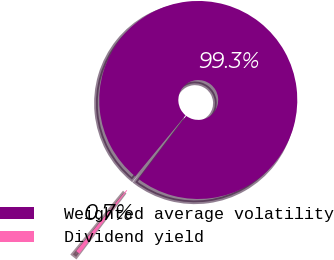<chart> <loc_0><loc_0><loc_500><loc_500><pie_chart><fcel>Weighted average volatility<fcel>Dividend yield<nl><fcel>99.34%<fcel>0.66%<nl></chart> 